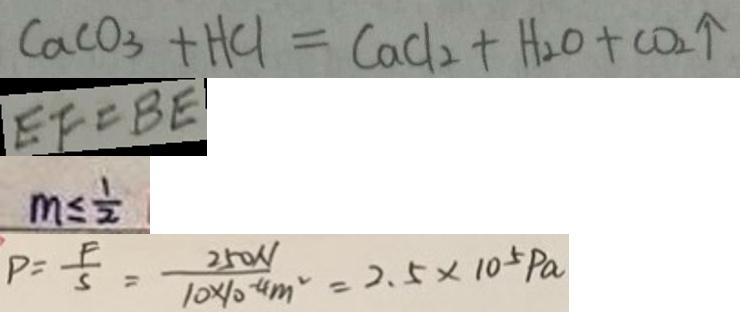Convert formula to latex. <formula><loc_0><loc_0><loc_500><loc_500>C a C O _ { 3 } + H C l = C a C l _ { 2 } + H _ { 2 } O + C O _ { 2 } \uparrow 
 E F = B E 
 m \leq \frac { 1 } { 2 } 
 P = \frac { F } { s } = \frac { 2 5 0 N } { 1 0 \times 1 0 ^ { - 4 } m ^ { 2 } } = 2 . 5 \times 1 0 ^ { 5 } P a</formula> 